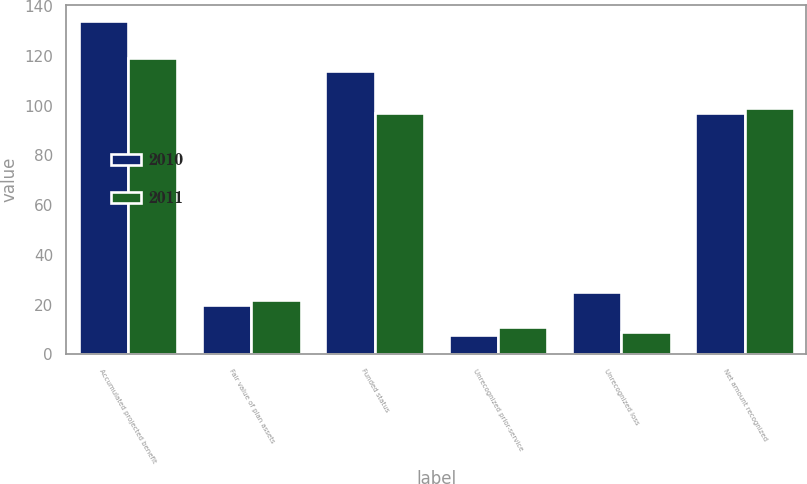Convert chart to OTSL. <chart><loc_0><loc_0><loc_500><loc_500><stacked_bar_chart><ecel><fcel>Accumulated projected benefit<fcel>Fair value of plan assets<fcel>Funded status<fcel>Unrecognized prior-service<fcel>Unrecognized loss<fcel>Net amount recognized<nl><fcel>2010<fcel>134<fcel>20<fcel>114<fcel>8<fcel>25<fcel>97<nl><fcel>2011<fcel>119<fcel>22<fcel>97<fcel>11<fcel>9<fcel>99<nl></chart> 